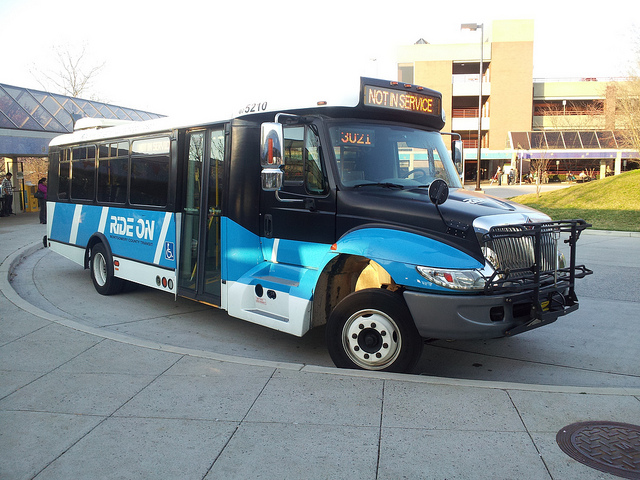<image>Is the wind blowing to the right? It is unknown if the wind is blowing to the right. Is the wind blowing to the right? I don't know if the wind is blowing to the right. It seems like the wind is not blowing to the right. 